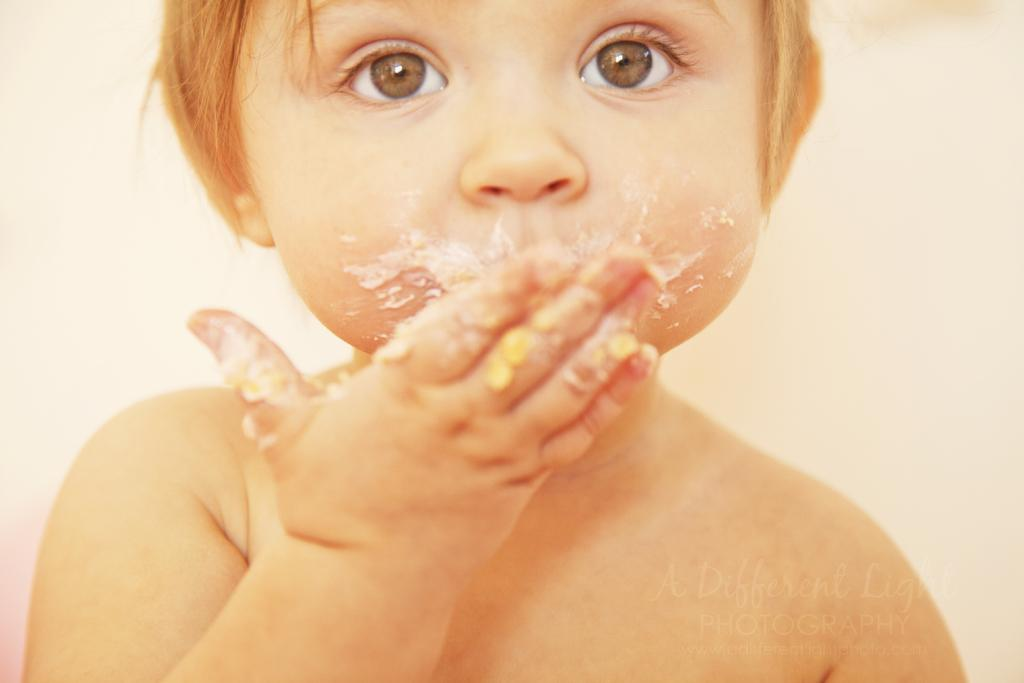Who is the main subject in the picture? The main subject in the picture is a baby boy. Where is the baby boy located in the image? The baby boy is sitting near a wall. What is the baby boy doing in the picture? The baby boy is eating food. Is there any additional information about the image? Yes, there is a watermark in the bottom right corner of the image. How many clocks are hanging on the wall behind the baby boy? There are no clocks visible in the image; the baby boy is sitting near a wall, but no clocks are mentioned. What type of jewel is the baby boy wearing in the image? There is no mention of any jewelry or jewels in the image; the baby boy is simply eating food while sitting near a wall. 